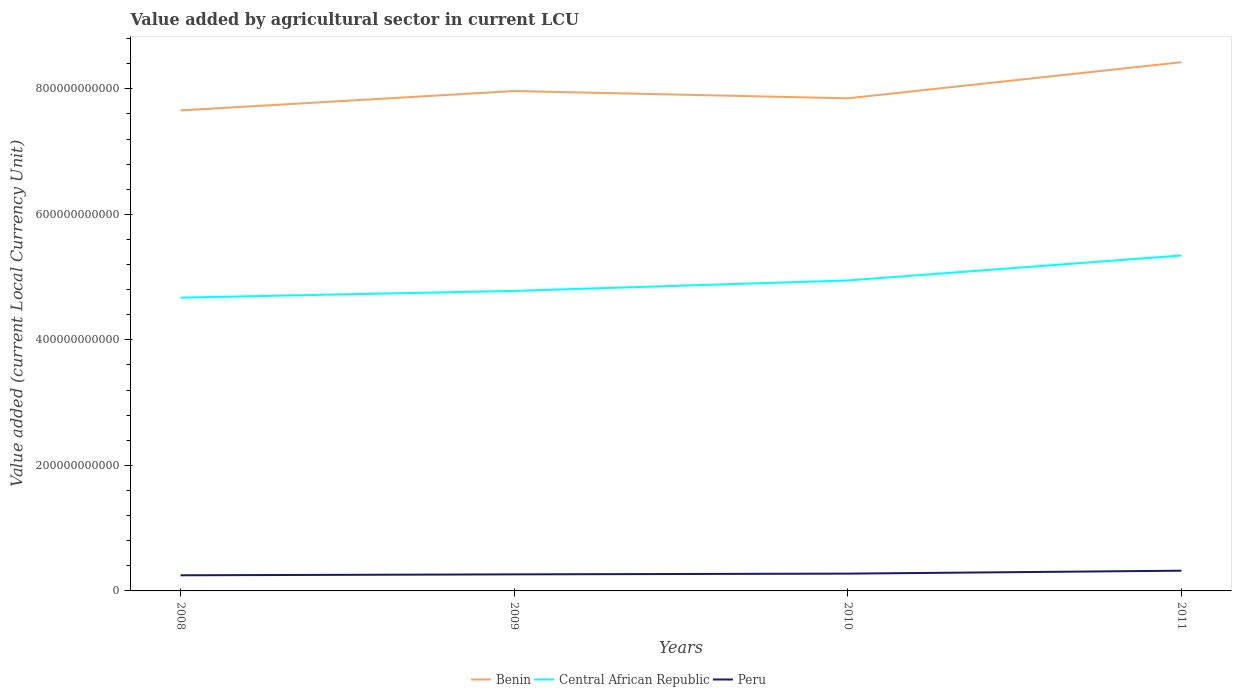Does the line corresponding to Peru intersect with the line corresponding to Benin?
Make the answer very short. No. Is the number of lines equal to the number of legend labels?
Your answer should be compact. Yes. Across all years, what is the maximum value added by agricultural sector in Benin?
Provide a short and direct response. 7.66e+11. What is the total value added by agricultural sector in Benin in the graph?
Ensure brevity in your answer.  -7.68e+1. What is the difference between the highest and the second highest value added by agricultural sector in Central African Republic?
Offer a terse response. 6.72e+1. Is the value added by agricultural sector in Benin strictly greater than the value added by agricultural sector in Central African Republic over the years?
Ensure brevity in your answer.  No. How many lines are there?
Your response must be concise. 3. How many years are there in the graph?
Provide a short and direct response. 4. What is the difference between two consecutive major ticks on the Y-axis?
Your answer should be very brief. 2.00e+11. Are the values on the major ticks of Y-axis written in scientific E-notation?
Your answer should be very brief. No. Does the graph contain grids?
Provide a short and direct response. No. Where does the legend appear in the graph?
Offer a terse response. Bottom center. How many legend labels are there?
Give a very brief answer. 3. How are the legend labels stacked?
Your answer should be compact. Horizontal. What is the title of the graph?
Provide a succinct answer. Value added by agricultural sector in current LCU. What is the label or title of the Y-axis?
Your response must be concise. Value added (current Local Currency Unit). What is the Value added (current Local Currency Unit) in Benin in 2008?
Provide a short and direct response. 7.66e+11. What is the Value added (current Local Currency Unit) in Central African Republic in 2008?
Your answer should be very brief. 4.67e+11. What is the Value added (current Local Currency Unit) of Peru in 2008?
Your answer should be compact. 2.49e+1. What is the Value added (current Local Currency Unit) of Benin in 2009?
Give a very brief answer. 7.96e+11. What is the Value added (current Local Currency Unit) in Central African Republic in 2009?
Keep it short and to the point. 4.78e+11. What is the Value added (current Local Currency Unit) of Peru in 2009?
Ensure brevity in your answer.  2.64e+1. What is the Value added (current Local Currency Unit) in Benin in 2010?
Your answer should be compact. 7.85e+11. What is the Value added (current Local Currency Unit) in Central African Republic in 2010?
Your answer should be very brief. 4.95e+11. What is the Value added (current Local Currency Unit) in Peru in 2010?
Provide a short and direct response. 2.76e+1. What is the Value added (current Local Currency Unit) in Benin in 2011?
Provide a succinct answer. 8.42e+11. What is the Value added (current Local Currency Unit) in Central African Republic in 2011?
Provide a short and direct response. 5.34e+11. What is the Value added (current Local Currency Unit) of Peru in 2011?
Your response must be concise. 3.22e+1. Across all years, what is the maximum Value added (current Local Currency Unit) in Benin?
Give a very brief answer. 8.42e+11. Across all years, what is the maximum Value added (current Local Currency Unit) of Central African Republic?
Give a very brief answer. 5.34e+11. Across all years, what is the maximum Value added (current Local Currency Unit) of Peru?
Your answer should be compact. 3.22e+1. Across all years, what is the minimum Value added (current Local Currency Unit) in Benin?
Your answer should be very brief. 7.66e+11. Across all years, what is the minimum Value added (current Local Currency Unit) of Central African Republic?
Make the answer very short. 4.67e+11. Across all years, what is the minimum Value added (current Local Currency Unit) of Peru?
Give a very brief answer. 2.49e+1. What is the total Value added (current Local Currency Unit) in Benin in the graph?
Offer a very short reply. 3.19e+12. What is the total Value added (current Local Currency Unit) of Central African Republic in the graph?
Provide a succinct answer. 1.97e+12. What is the total Value added (current Local Currency Unit) in Peru in the graph?
Your answer should be compact. 1.11e+11. What is the difference between the Value added (current Local Currency Unit) in Benin in 2008 and that in 2009?
Ensure brevity in your answer.  -3.09e+1. What is the difference between the Value added (current Local Currency Unit) in Central African Republic in 2008 and that in 2009?
Your answer should be compact. -1.07e+1. What is the difference between the Value added (current Local Currency Unit) of Peru in 2008 and that in 2009?
Give a very brief answer. -1.47e+09. What is the difference between the Value added (current Local Currency Unit) of Benin in 2008 and that in 2010?
Ensure brevity in your answer.  -1.93e+1. What is the difference between the Value added (current Local Currency Unit) of Central African Republic in 2008 and that in 2010?
Offer a very short reply. -2.74e+1. What is the difference between the Value added (current Local Currency Unit) in Peru in 2008 and that in 2010?
Provide a short and direct response. -2.63e+09. What is the difference between the Value added (current Local Currency Unit) of Benin in 2008 and that in 2011?
Your answer should be very brief. -7.68e+1. What is the difference between the Value added (current Local Currency Unit) in Central African Republic in 2008 and that in 2011?
Your response must be concise. -6.72e+1. What is the difference between the Value added (current Local Currency Unit) of Peru in 2008 and that in 2011?
Your answer should be very brief. -7.31e+09. What is the difference between the Value added (current Local Currency Unit) of Benin in 2009 and that in 2010?
Offer a terse response. 1.16e+1. What is the difference between the Value added (current Local Currency Unit) of Central African Republic in 2009 and that in 2010?
Offer a very short reply. -1.66e+1. What is the difference between the Value added (current Local Currency Unit) in Peru in 2009 and that in 2010?
Make the answer very short. -1.17e+09. What is the difference between the Value added (current Local Currency Unit) of Benin in 2009 and that in 2011?
Your response must be concise. -4.59e+1. What is the difference between the Value added (current Local Currency Unit) in Central African Republic in 2009 and that in 2011?
Keep it short and to the point. -5.64e+1. What is the difference between the Value added (current Local Currency Unit) in Peru in 2009 and that in 2011?
Ensure brevity in your answer.  -5.84e+09. What is the difference between the Value added (current Local Currency Unit) in Benin in 2010 and that in 2011?
Offer a terse response. -5.75e+1. What is the difference between the Value added (current Local Currency Unit) of Central African Republic in 2010 and that in 2011?
Offer a terse response. -3.98e+1. What is the difference between the Value added (current Local Currency Unit) in Peru in 2010 and that in 2011?
Your response must be concise. -4.68e+09. What is the difference between the Value added (current Local Currency Unit) of Benin in 2008 and the Value added (current Local Currency Unit) of Central African Republic in 2009?
Provide a succinct answer. 2.88e+11. What is the difference between the Value added (current Local Currency Unit) of Benin in 2008 and the Value added (current Local Currency Unit) of Peru in 2009?
Make the answer very short. 7.39e+11. What is the difference between the Value added (current Local Currency Unit) of Central African Republic in 2008 and the Value added (current Local Currency Unit) of Peru in 2009?
Provide a short and direct response. 4.41e+11. What is the difference between the Value added (current Local Currency Unit) in Benin in 2008 and the Value added (current Local Currency Unit) in Central African Republic in 2010?
Your response must be concise. 2.71e+11. What is the difference between the Value added (current Local Currency Unit) of Benin in 2008 and the Value added (current Local Currency Unit) of Peru in 2010?
Provide a succinct answer. 7.38e+11. What is the difference between the Value added (current Local Currency Unit) in Central African Republic in 2008 and the Value added (current Local Currency Unit) in Peru in 2010?
Your answer should be compact. 4.40e+11. What is the difference between the Value added (current Local Currency Unit) in Benin in 2008 and the Value added (current Local Currency Unit) in Central African Republic in 2011?
Ensure brevity in your answer.  2.31e+11. What is the difference between the Value added (current Local Currency Unit) in Benin in 2008 and the Value added (current Local Currency Unit) in Peru in 2011?
Your response must be concise. 7.33e+11. What is the difference between the Value added (current Local Currency Unit) in Central African Republic in 2008 and the Value added (current Local Currency Unit) in Peru in 2011?
Provide a short and direct response. 4.35e+11. What is the difference between the Value added (current Local Currency Unit) of Benin in 2009 and the Value added (current Local Currency Unit) of Central African Republic in 2010?
Provide a short and direct response. 3.02e+11. What is the difference between the Value added (current Local Currency Unit) in Benin in 2009 and the Value added (current Local Currency Unit) in Peru in 2010?
Provide a succinct answer. 7.69e+11. What is the difference between the Value added (current Local Currency Unit) of Central African Republic in 2009 and the Value added (current Local Currency Unit) of Peru in 2010?
Provide a succinct answer. 4.50e+11. What is the difference between the Value added (current Local Currency Unit) in Benin in 2009 and the Value added (current Local Currency Unit) in Central African Republic in 2011?
Offer a very short reply. 2.62e+11. What is the difference between the Value added (current Local Currency Unit) of Benin in 2009 and the Value added (current Local Currency Unit) of Peru in 2011?
Make the answer very short. 7.64e+11. What is the difference between the Value added (current Local Currency Unit) in Central African Republic in 2009 and the Value added (current Local Currency Unit) in Peru in 2011?
Offer a very short reply. 4.46e+11. What is the difference between the Value added (current Local Currency Unit) in Benin in 2010 and the Value added (current Local Currency Unit) in Central African Republic in 2011?
Provide a short and direct response. 2.50e+11. What is the difference between the Value added (current Local Currency Unit) in Benin in 2010 and the Value added (current Local Currency Unit) in Peru in 2011?
Ensure brevity in your answer.  7.53e+11. What is the difference between the Value added (current Local Currency Unit) in Central African Republic in 2010 and the Value added (current Local Currency Unit) in Peru in 2011?
Your answer should be very brief. 4.62e+11. What is the average Value added (current Local Currency Unit) of Benin per year?
Keep it short and to the point. 7.97e+11. What is the average Value added (current Local Currency Unit) of Central African Republic per year?
Your response must be concise. 4.94e+11. What is the average Value added (current Local Currency Unit) in Peru per year?
Offer a very short reply. 2.78e+1. In the year 2008, what is the difference between the Value added (current Local Currency Unit) of Benin and Value added (current Local Currency Unit) of Central African Republic?
Your answer should be compact. 2.98e+11. In the year 2008, what is the difference between the Value added (current Local Currency Unit) of Benin and Value added (current Local Currency Unit) of Peru?
Offer a terse response. 7.41e+11. In the year 2008, what is the difference between the Value added (current Local Currency Unit) in Central African Republic and Value added (current Local Currency Unit) in Peru?
Your answer should be compact. 4.42e+11. In the year 2009, what is the difference between the Value added (current Local Currency Unit) of Benin and Value added (current Local Currency Unit) of Central African Republic?
Offer a terse response. 3.18e+11. In the year 2009, what is the difference between the Value added (current Local Currency Unit) of Benin and Value added (current Local Currency Unit) of Peru?
Your answer should be very brief. 7.70e+11. In the year 2009, what is the difference between the Value added (current Local Currency Unit) in Central African Republic and Value added (current Local Currency Unit) in Peru?
Ensure brevity in your answer.  4.52e+11. In the year 2010, what is the difference between the Value added (current Local Currency Unit) of Benin and Value added (current Local Currency Unit) of Central African Republic?
Offer a very short reply. 2.90e+11. In the year 2010, what is the difference between the Value added (current Local Currency Unit) of Benin and Value added (current Local Currency Unit) of Peru?
Offer a very short reply. 7.57e+11. In the year 2010, what is the difference between the Value added (current Local Currency Unit) of Central African Republic and Value added (current Local Currency Unit) of Peru?
Your response must be concise. 4.67e+11. In the year 2011, what is the difference between the Value added (current Local Currency Unit) of Benin and Value added (current Local Currency Unit) of Central African Republic?
Your response must be concise. 3.08e+11. In the year 2011, what is the difference between the Value added (current Local Currency Unit) of Benin and Value added (current Local Currency Unit) of Peru?
Ensure brevity in your answer.  8.10e+11. In the year 2011, what is the difference between the Value added (current Local Currency Unit) in Central African Republic and Value added (current Local Currency Unit) in Peru?
Provide a succinct answer. 5.02e+11. What is the ratio of the Value added (current Local Currency Unit) in Benin in 2008 to that in 2009?
Keep it short and to the point. 0.96. What is the ratio of the Value added (current Local Currency Unit) of Central African Republic in 2008 to that in 2009?
Make the answer very short. 0.98. What is the ratio of the Value added (current Local Currency Unit) in Peru in 2008 to that in 2009?
Your answer should be very brief. 0.94. What is the ratio of the Value added (current Local Currency Unit) in Benin in 2008 to that in 2010?
Give a very brief answer. 0.98. What is the ratio of the Value added (current Local Currency Unit) in Central African Republic in 2008 to that in 2010?
Your answer should be very brief. 0.94. What is the ratio of the Value added (current Local Currency Unit) in Peru in 2008 to that in 2010?
Your answer should be compact. 0.9. What is the ratio of the Value added (current Local Currency Unit) in Benin in 2008 to that in 2011?
Keep it short and to the point. 0.91. What is the ratio of the Value added (current Local Currency Unit) of Central African Republic in 2008 to that in 2011?
Ensure brevity in your answer.  0.87. What is the ratio of the Value added (current Local Currency Unit) of Peru in 2008 to that in 2011?
Your answer should be very brief. 0.77. What is the ratio of the Value added (current Local Currency Unit) of Benin in 2009 to that in 2010?
Your response must be concise. 1.01. What is the ratio of the Value added (current Local Currency Unit) in Central African Republic in 2009 to that in 2010?
Make the answer very short. 0.97. What is the ratio of the Value added (current Local Currency Unit) of Peru in 2009 to that in 2010?
Your response must be concise. 0.96. What is the ratio of the Value added (current Local Currency Unit) in Benin in 2009 to that in 2011?
Give a very brief answer. 0.95. What is the ratio of the Value added (current Local Currency Unit) in Central African Republic in 2009 to that in 2011?
Keep it short and to the point. 0.89. What is the ratio of the Value added (current Local Currency Unit) of Peru in 2009 to that in 2011?
Ensure brevity in your answer.  0.82. What is the ratio of the Value added (current Local Currency Unit) of Benin in 2010 to that in 2011?
Make the answer very short. 0.93. What is the ratio of the Value added (current Local Currency Unit) in Central African Republic in 2010 to that in 2011?
Offer a terse response. 0.93. What is the ratio of the Value added (current Local Currency Unit) of Peru in 2010 to that in 2011?
Offer a very short reply. 0.85. What is the difference between the highest and the second highest Value added (current Local Currency Unit) of Benin?
Offer a terse response. 4.59e+1. What is the difference between the highest and the second highest Value added (current Local Currency Unit) of Central African Republic?
Your response must be concise. 3.98e+1. What is the difference between the highest and the second highest Value added (current Local Currency Unit) in Peru?
Make the answer very short. 4.68e+09. What is the difference between the highest and the lowest Value added (current Local Currency Unit) of Benin?
Offer a terse response. 7.68e+1. What is the difference between the highest and the lowest Value added (current Local Currency Unit) of Central African Republic?
Offer a terse response. 6.72e+1. What is the difference between the highest and the lowest Value added (current Local Currency Unit) of Peru?
Make the answer very short. 7.31e+09. 